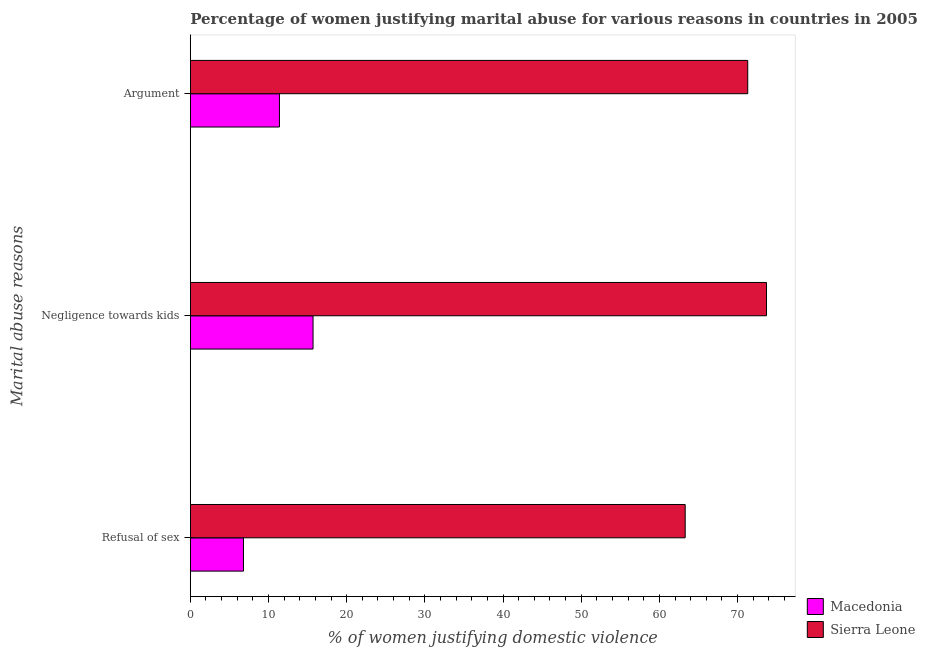How many different coloured bars are there?
Your answer should be compact. 2. How many groups of bars are there?
Give a very brief answer. 3. Are the number of bars on each tick of the Y-axis equal?
Provide a succinct answer. Yes. What is the label of the 1st group of bars from the top?
Your answer should be very brief. Argument. What is the percentage of women justifying domestic violence due to negligence towards kids in Sierra Leone?
Offer a terse response. 73.7. Across all countries, what is the maximum percentage of women justifying domestic violence due to negligence towards kids?
Offer a very short reply. 73.7. Across all countries, what is the minimum percentage of women justifying domestic violence due to negligence towards kids?
Your answer should be very brief. 15.7. In which country was the percentage of women justifying domestic violence due to arguments maximum?
Provide a short and direct response. Sierra Leone. In which country was the percentage of women justifying domestic violence due to arguments minimum?
Make the answer very short. Macedonia. What is the total percentage of women justifying domestic violence due to arguments in the graph?
Provide a short and direct response. 82.7. What is the difference between the percentage of women justifying domestic violence due to refusal of sex in Macedonia and that in Sierra Leone?
Offer a terse response. -56.5. What is the difference between the percentage of women justifying domestic violence due to arguments in Sierra Leone and the percentage of women justifying domestic violence due to negligence towards kids in Macedonia?
Provide a short and direct response. 55.6. What is the average percentage of women justifying domestic violence due to refusal of sex per country?
Ensure brevity in your answer.  35.05. What is the difference between the percentage of women justifying domestic violence due to refusal of sex and percentage of women justifying domestic violence due to negligence towards kids in Macedonia?
Provide a short and direct response. -8.9. What is the ratio of the percentage of women justifying domestic violence due to negligence towards kids in Macedonia to that in Sierra Leone?
Ensure brevity in your answer.  0.21. What is the difference between the highest and the second highest percentage of women justifying domestic violence due to arguments?
Offer a terse response. 59.9. What is the difference between the highest and the lowest percentage of women justifying domestic violence due to refusal of sex?
Your response must be concise. 56.5. In how many countries, is the percentage of women justifying domestic violence due to refusal of sex greater than the average percentage of women justifying domestic violence due to refusal of sex taken over all countries?
Ensure brevity in your answer.  1. What does the 1st bar from the top in Argument represents?
Provide a succinct answer. Sierra Leone. What does the 1st bar from the bottom in Negligence towards kids represents?
Provide a succinct answer. Macedonia. Is it the case that in every country, the sum of the percentage of women justifying domestic violence due to refusal of sex and percentage of women justifying domestic violence due to negligence towards kids is greater than the percentage of women justifying domestic violence due to arguments?
Your response must be concise. Yes. Are all the bars in the graph horizontal?
Provide a succinct answer. Yes. Where does the legend appear in the graph?
Ensure brevity in your answer.  Bottom right. How many legend labels are there?
Offer a very short reply. 2. What is the title of the graph?
Offer a terse response. Percentage of women justifying marital abuse for various reasons in countries in 2005. What is the label or title of the X-axis?
Keep it short and to the point. % of women justifying domestic violence. What is the label or title of the Y-axis?
Provide a short and direct response. Marital abuse reasons. What is the % of women justifying domestic violence of Macedonia in Refusal of sex?
Make the answer very short. 6.8. What is the % of women justifying domestic violence in Sierra Leone in Refusal of sex?
Make the answer very short. 63.3. What is the % of women justifying domestic violence of Sierra Leone in Negligence towards kids?
Offer a terse response. 73.7. What is the % of women justifying domestic violence of Macedonia in Argument?
Your answer should be compact. 11.4. What is the % of women justifying domestic violence in Sierra Leone in Argument?
Give a very brief answer. 71.3. Across all Marital abuse reasons, what is the maximum % of women justifying domestic violence in Macedonia?
Offer a very short reply. 15.7. Across all Marital abuse reasons, what is the maximum % of women justifying domestic violence in Sierra Leone?
Give a very brief answer. 73.7. Across all Marital abuse reasons, what is the minimum % of women justifying domestic violence of Macedonia?
Provide a short and direct response. 6.8. Across all Marital abuse reasons, what is the minimum % of women justifying domestic violence in Sierra Leone?
Your answer should be very brief. 63.3. What is the total % of women justifying domestic violence of Macedonia in the graph?
Offer a very short reply. 33.9. What is the total % of women justifying domestic violence in Sierra Leone in the graph?
Give a very brief answer. 208.3. What is the difference between the % of women justifying domestic violence in Macedonia in Refusal of sex and that in Argument?
Provide a succinct answer. -4.6. What is the difference between the % of women justifying domestic violence in Macedonia in Negligence towards kids and that in Argument?
Your response must be concise. 4.3. What is the difference between the % of women justifying domestic violence of Macedonia in Refusal of sex and the % of women justifying domestic violence of Sierra Leone in Negligence towards kids?
Offer a very short reply. -66.9. What is the difference between the % of women justifying domestic violence in Macedonia in Refusal of sex and the % of women justifying domestic violence in Sierra Leone in Argument?
Ensure brevity in your answer.  -64.5. What is the difference between the % of women justifying domestic violence of Macedonia in Negligence towards kids and the % of women justifying domestic violence of Sierra Leone in Argument?
Offer a very short reply. -55.6. What is the average % of women justifying domestic violence of Sierra Leone per Marital abuse reasons?
Your answer should be very brief. 69.43. What is the difference between the % of women justifying domestic violence in Macedonia and % of women justifying domestic violence in Sierra Leone in Refusal of sex?
Your answer should be very brief. -56.5. What is the difference between the % of women justifying domestic violence of Macedonia and % of women justifying domestic violence of Sierra Leone in Negligence towards kids?
Ensure brevity in your answer.  -58. What is the difference between the % of women justifying domestic violence in Macedonia and % of women justifying domestic violence in Sierra Leone in Argument?
Give a very brief answer. -59.9. What is the ratio of the % of women justifying domestic violence in Macedonia in Refusal of sex to that in Negligence towards kids?
Make the answer very short. 0.43. What is the ratio of the % of women justifying domestic violence of Sierra Leone in Refusal of sex to that in Negligence towards kids?
Offer a terse response. 0.86. What is the ratio of the % of women justifying domestic violence of Macedonia in Refusal of sex to that in Argument?
Your answer should be compact. 0.6. What is the ratio of the % of women justifying domestic violence in Sierra Leone in Refusal of sex to that in Argument?
Ensure brevity in your answer.  0.89. What is the ratio of the % of women justifying domestic violence of Macedonia in Negligence towards kids to that in Argument?
Ensure brevity in your answer.  1.38. What is the ratio of the % of women justifying domestic violence in Sierra Leone in Negligence towards kids to that in Argument?
Ensure brevity in your answer.  1.03. What is the difference between the highest and the second highest % of women justifying domestic violence of Macedonia?
Give a very brief answer. 4.3. What is the difference between the highest and the second highest % of women justifying domestic violence in Sierra Leone?
Ensure brevity in your answer.  2.4. What is the difference between the highest and the lowest % of women justifying domestic violence of Macedonia?
Give a very brief answer. 8.9. 